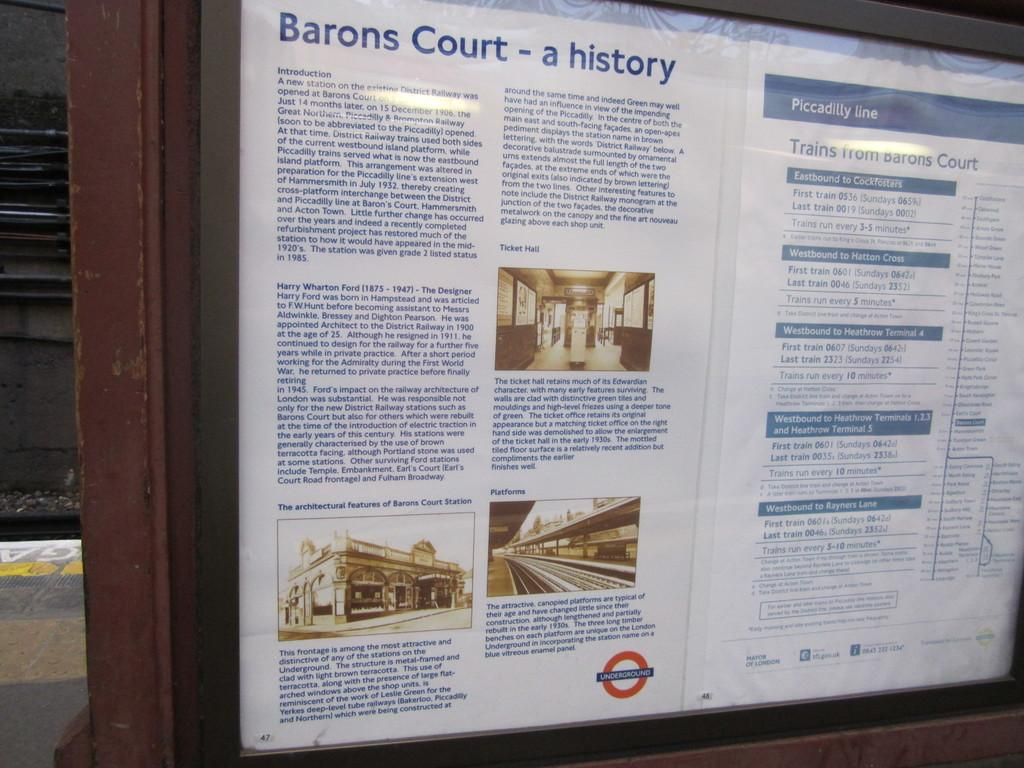<image>
Share a concise interpretation of the image provided. Blue and white sign that says "Barons Court" on the top. 